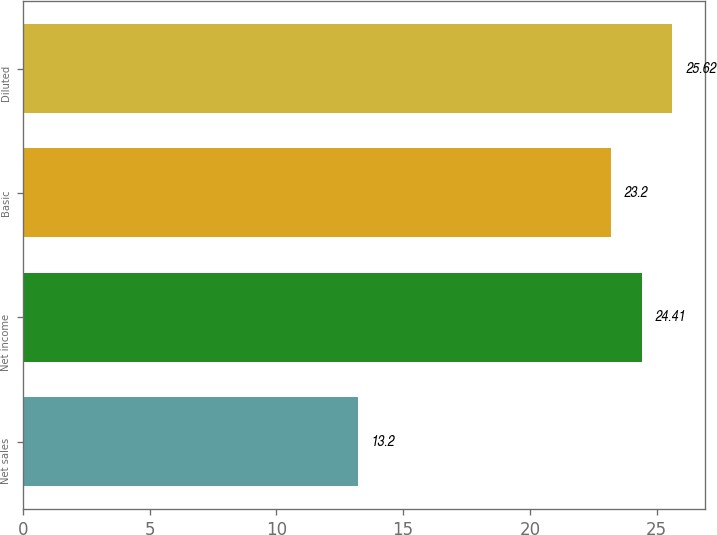<chart> <loc_0><loc_0><loc_500><loc_500><bar_chart><fcel>Net sales<fcel>Net income<fcel>Basic<fcel>Diluted<nl><fcel>13.2<fcel>24.41<fcel>23.2<fcel>25.62<nl></chart> 